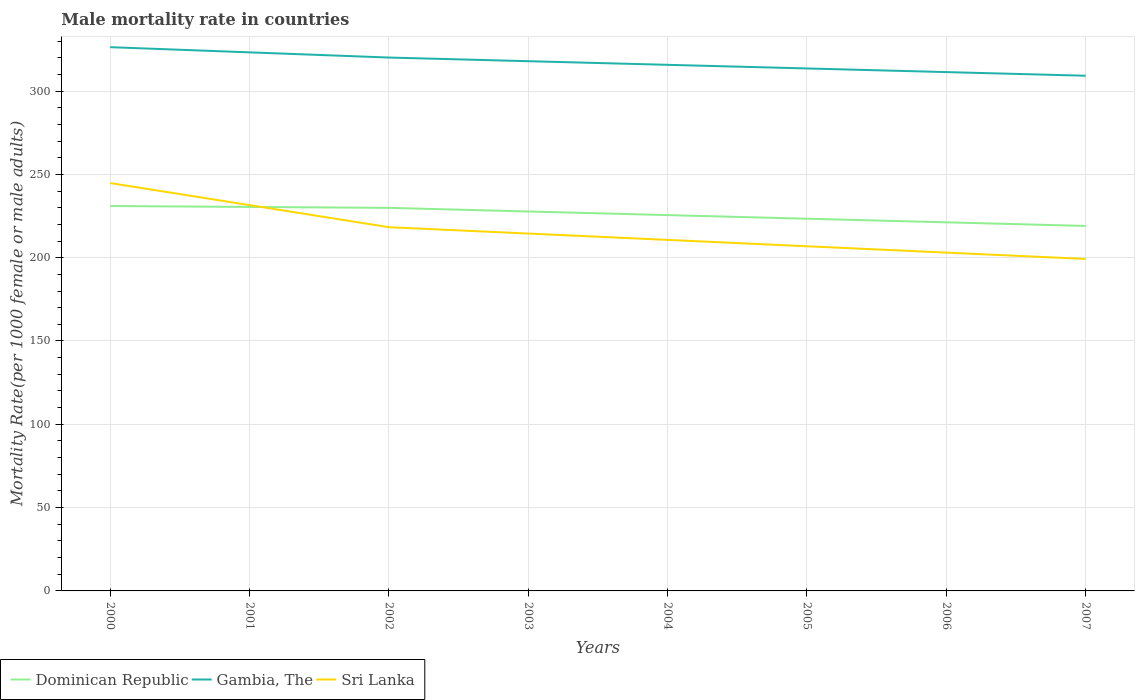How many different coloured lines are there?
Offer a very short reply. 3. Across all years, what is the maximum male mortality rate in Gambia, The?
Provide a succinct answer. 309.21. In which year was the male mortality rate in Sri Lanka maximum?
Give a very brief answer. 2007. What is the total male mortality rate in Sri Lanka in the graph?
Give a very brief answer. 19.05. What is the difference between the highest and the second highest male mortality rate in Gambia, The?
Provide a succinct answer. 17.14. What is the difference between the highest and the lowest male mortality rate in Gambia, The?
Make the answer very short. 4. Is the male mortality rate in Sri Lanka strictly greater than the male mortality rate in Gambia, The over the years?
Offer a very short reply. Yes. How many years are there in the graph?
Offer a very short reply. 8. Are the values on the major ticks of Y-axis written in scientific E-notation?
Make the answer very short. No. Where does the legend appear in the graph?
Keep it short and to the point. Bottom left. What is the title of the graph?
Offer a very short reply. Male mortality rate in countries. What is the label or title of the Y-axis?
Provide a succinct answer. Mortality Rate(per 1000 female or male adults). What is the Mortality Rate(per 1000 female or male adults) of Dominican Republic in 2000?
Keep it short and to the point. 231.02. What is the Mortality Rate(per 1000 female or male adults) of Gambia, The in 2000?
Your answer should be compact. 326.36. What is the Mortality Rate(per 1000 female or male adults) of Sri Lanka in 2000?
Offer a very short reply. 244.79. What is the Mortality Rate(per 1000 female or male adults) in Dominican Republic in 2001?
Make the answer very short. 230.46. What is the Mortality Rate(per 1000 female or male adults) of Gambia, The in 2001?
Ensure brevity in your answer.  323.24. What is the Mortality Rate(per 1000 female or male adults) in Sri Lanka in 2001?
Your answer should be compact. 231.54. What is the Mortality Rate(per 1000 female or male adults) of Dominican Republic in 2002?
Give a very brief answer. 229.91. What is the Mortality Rate(per 1000 female or male adults) in Gambia, The in 2002?
Ensure brevity in your answer.  320.12. What is the Mortality Rate(per 1000 female or male adults) in Sri Lanka in 2002?
Keep it short and to the point. 218.29. What is the Mortality Rate(per 1000 female or male adults) of Dominican Republic in 2003?
Give a very brief answer. 227.74. What is the Mortality Rate(per 1000 female or male adults) of Gambia, The in 2003?
Provide a succinct answer. 317.94. What is the Mortality Rate(per 1000 female or male adults) of Sri Lanka in 2003?
Offer a very short reply. 214.48. What is the Mortality Rate(per 1000 female or male adults) in Dominican Republic in 2004?
Provide a short and direct response. 225.56. What is the Mortality Rate(per 1000 female or male adults) in Gambia, The in 2004?
Make the answer very short. 315.76. What is the Mortality Rate(per 1000 female or male adults) in Sri Lanka in 2004?
Give a very brief answer. 210.67. What is the Mortality Rate(per 1000 female or male adults) of Dominican Republic in 2005?
Give a very brief answer. 223.39. What is the Mortality Rate(per 1000 female or male adults) of Gambia, The in 2005?
Offer a very short reply. 313.58. What is the Mortality Rate(per 1000 female or male adults) of Sri Lanka in 2005?
Give a very brief answer. 206.86. What is the Mortality Rate(per 1000 female or male adults) in Dominican Republic in 2006?
Your answer should be very brief. 221.22. What is the Mortality Rate(per 1000 female or male adults) in Gambia, The in 2006?
Your answer should be compact. 311.39. What is the Mortality Rate(per 1000 female or male adults) in Sri Lanka in 2006?
Provide a succinct answer. 203.05. What is the Mortality Rate(per 1000 female or male adults) of Dominican Republic in 2007?
Offer a very short reply. 219.05. What is the Mortality Rate(per 1000 female or male adults) of Gambia, The in 2007?
Provide a succinct answer. 309.21. What is the Mortality Rate(per 1000 female or male adults) in Sri Lanka in 2007?
Your answer should be compact. 199.24. Across all years, what is the maximum Mortality Rate(per 1000 female or male adults) in Dominican Republic?
Keep it short and to the point. 231.02. Across all years, what is the maximum Mortality Rate(per 1000 female or male adults) in Gambia, The?
Your answer should be compact. 326.36. Across all years, what is the maximum Mortality Rate(per 1000 female or male adults) in Sri Lanka?
Offer a very short reply. 244.79. Across all years, what is the minimum Mortality Rate(per 1000 female or male adults) of Dominican Republic?
Make the answer very short. 219.05. Across all years, what is the minimum Mortality Rate(per 1000 female or male adults) in Gambia, The?
Give a very brief answer. 309.21. Across all years, what is the minimum Mortality Rate(per 1000 female or male adults) in Sri Lanka?
Give a very brief answer. 199.24. What is the total Mortality Rate(per 1000 female or male adults) in Dominican Republic in the graph?
Offer a terse response. 1808.36. What is the total Mortality Rate(per 1000 female or male adults) in Gambia, The in the graph?
Make the answer very short. 2537.6. What is the total Mortality Rate(per 1000 female or male adults) of Sri Lanka in the graph?
Keep it short and to the point. 1728.93. What is the difference between the Mortality Rate(per 1000 female or male adults) of Dominican Republic in 2000 and that in 2001?
Your response must be concise. 0.56. What is the difference between the Mortality Rate(per 1000 female or male adults) in Gambia, The in 2000 and that in 2001?
Offer a terse response. 3.12. What is the difference between the Mortality Rate(per 1000 female or male adults) of Sri Lanka in 2000 and that in 2001?
Offer a terse response. 13.25. What is the difference between the Mortality Rate(per 1000 female or male adults) in Dominican Republic in 2000 and that in 2002?
Keep it short and to the point. 1.11. What is the difference between the Mortality Rate(per 1000 female or male adults) of Gambia, The in 2000 and that in 2002?
Provide a short and direct response. 6.23. What is the difference between the Mortality Rate(per 1000 female or male adults) of Sri Lanka in 2000 and that in 2002?
Your answer should be very brief. 26.5. What is the difference between the Mortality Rate(per 1000 female or male adults) in Dominican Republic in 2000 and that in 2003?
Keep it short and to the point. 3.29. What is the difference between the Mortality Rate(per 1000 female or male adults) in Gambia, The in 2000 and that in 2003?
Give a very brief answer. 8.41. What is the difference between the Mortality Rate(per 1000 female or male adults) in Sri Lanka in 2000 and that in 2003?
Keep it short and to the point. 30.31. What is the difference between the Mortality Rate(per 1000 female or male adults) in Dominican Republic in 2000 and that in 2004?
Your answer should be compact. 5.46. What is the difference between the Mortality Rate(per 1000 female or male adults) in Gambia, The in 2000 and that in 2004?
Keep it short and to the point. 10.6. What is the difference between the Mortality Rate(per 1000 female or male adults) of Sri Lanka in 2000 and that in 2004?
Your response must be concise. 34.12. What is the difference between the Mortality Rate(per 1000 female or male adults) of Dominican Republic in 2000 and that in 2005?
Keep it short and to the point. 7.63. What is the difference between the Mortality Rate(per 1000 female or male adults) in Gambia, The in 2000 and that in 2005?
Offer a very short reply. 12.78. What is the difference between the Mortality Rate(per 1000 female or male adults) in Sri Lanka in 2000 and that in 2005?
Keep it short and to the point. 37.93. What is the difference between the Mortality Rate(per 1000 female or male adults) of Dominican Republic in 2000 and that in 2006?
Make the answer very short. 9.8. What is the difference between the Mortality Rate(per 1000 female or male adults) of Gambia, The in 2000 and that in 2006?
Your answer should be compact. 14.96. What is the difference between the Mortality Rate(per 1000 female or male adults) in Sri Lanka in 2000 and that in 2006?
Keep it short and to the point. 41.74. What is the difference between the Mortality Rate(per 1000 female or male adults) of Dominican Republic in 2000 and that in 2007?
Make the answer very short. 11.97. What is the difference between the Mortality Rate(per 1000 female or male adults) in Gambia, The in 2000 and that in 2007?
Make the answer very short. 17.14. What is the difference between the Mortality Rate(per 1000 female or male adults) of Sri Lanka in 2000 and that in 2007?
Your answer should be very brief. 45.55. What is the difference between the Mortality Rate(per 1000 female or male adults) in Dominican Republic in 2001 and that in 2002?
Keep it short and to the point. 0.56. What is the difference between the Mortality Rate(per 1000 female or male adults) of Gambia, The in 2001 and that in 2002?
Offer a very short reply. 3.12. What is the difference between the Mortality Rate(per 1000 female or male adults) in Sri Lanka in 2001 and that in 2002?
Your answer should be very brief. 13.25. What is the difference between the Mortality Rate(per 1000 female or male adults) of Dominican Republic in 2001 and that in 2003?
Ensure brevity in your answer.  2.73. What is the difference between the Mortality Rate(per 1000 female or male adults) in Gambia, The in 2001 and that in 2003?
Offer a terse response. 5.3. What is the difference between the Mortality Rate(per 1000 female or male adults) in Sri Lanka in 2001 and that in 2003?
Ensure brevity in your answer.  17.06. What is the difference between the Mortality Rate(per 1000 female or male adults) of Dominican Republic in 2001 and that in 2004?
Your answer should be compact. 4.9. What is the difference between the Mortality Rate(per 1000 female or male adults) of Gambia, The in 2001 and that in 2004?
Your answer should be very brief. 7.48. What is the difference between the Mortality Rate(per 1000 female or male adults) in Sri Lanka in 2001 and that in 2004?
Offer a very short reply. 20.87. What is the difference between the Mortality Rate(per 1000 female or male adults) of Dominican Republic in 2001 and that in 2005?
Provide a succinct answer. 7.07. What is the difference between the Mortality Rate(per 1000 female or male adults) of Gambia, The in 2001 and that in 2005?
Your response must be concise. 9.66. What is the difference between the Mortality Rate(per 1000 female or male adults) of Sri Lanka in 2001 and that in 2005?
Your response must be concise. 24.68. What is the difference between the Mortality Rate(per 1000 female or male adults) in Dominican Republic in 2001 and that in 2006?
Provide a succinct answer. 9.24. What is the difference between the Mortality Rate(per 1000 female or male adults) of Gambia, The in 2001 and that in 2006?
Your response must be concise. 11.85. What is the difference between the Mortality Rate(per 1000 female or male adults) of Sri Lanka in 2001 and that in 2006?
Provide a short and direct response. 28.49. What is the difference between the Mortality Rate(per 1000 female or male adults) of Dominican Republic in 2001 and that in 2007?
Your response must be concise. 11.41. What is the difference between the Mortality Rate(per 1000 female or male adults) of Gambia, The in 2001 and that in 2007?
Your answer should be compact. 14.03. What is the difference between the Mortality Rate(per 1000 female or male adults) in Sri Lanka in 2001 and that in 2007?
Provide a short and direct response. 32.3. What is the difference between the Mortality Rate(per 1000 female or male adults) of Dominican Republic in 2002 and that in 2003?
Provide a short and direct response. 2.17. What is the difference between the Mortality Rate(per 1000 female or male adults) of Gambia, The in 2002 and that in 2003?
Make the answer very short. 2.18. What is the difference between the Mortality Rate(per 1000 female or male adults) of Sri Lanka in 2002 and that in 2003?
Your answer should be compact. 3.81. What is the difference between the Mortality Rate(per 1000 female or male adults) in Dominican Republic in 2002 and that in 2004?
Offer a terse response. 4.34. What is the difference between the Mortality Rate(per 1000 female or male adults) of Gambia, The in 2002 and that in 2004?
Your answer should be very brief. 4.37. What is the difference between the Mortality Rate(per 1000 female or male adults) in Sri Lanka in 2002 and that in 2004?
Ensure brevity in your answer.  7.62. What is the difference between the Mortality Rate(per 1000 female or male adults) of Dominican Republic in 2002 and that in 2005?
Your answer should be compact. 6.51. What is the difference between the Mortality Rate(per 1000 female or male adults) in Gambia, The in 2002 and that in 2005?
Offer a terse response. 6.55. What is the difference between the Mortality Rate(per 1000 female or male adults) of Sri Lanka in 2002 and that in 2005?
Offer a terse response. 11.43. What is the difference between the Mortality Rate(per 1000 female or male adults) of Dominican Republic in 2002 and that in 2006?
Provide a short and direct response. 8.69. What is the difference between the Mortality Rate(per 1000 female or male adults) of Gambia, The in 2002 and that in 2006?
Your response must be concise. 8.73. What is the difference between the Mortality Rate(per 1000 female or male adults) in Sri Lanka in 2002 and that in 2006?
Give a very brief answer. 15.24. What is the difference between the Mortality Rate(per 1000 female or male adults) in Dominican Republic in 2002 and that in 2007?
Give a very brief answer. 10.86. What is the difference between the Mortality Rate(per 1000 female or male adults) in Gambia, The in 2002 and that in 2007?
Keep it short and to the point. 10.91. What is the difference between the Mortality Rate(per 1000 female or male adults) in Sri Lanka in 2002 and that in 2007?
Provide a succinct answer. 19.05. What is the difference between the Mortality Rate(per 1000 female or male adults) of Dominican Republic in 2003 and that in 2004?
Provide a short and direct response. 2.17. What is the difference between the Mortality Rate(per 1000 female or male adults) in Gambia, The in 2003 and that in 2004?
Keep it short and to the point. 2.18. What is the difference between the Mortality Rate(per 1000 female or male adults) in Sri Lanka in 2003 and that in 2004?
Provide a short and direct response. 3.81. What is the difference between the Mortality Rate(per 1000 female or male adults) of Dominican Republic in 2003 and that in 2005?
Provide a short and direct response. 4.34. What is the difference between the Mortality Rate(per 1000 female or male adults) of Gambia, The in 2003 and that in 2005?
Offer a very short reply. 4.37. What is the difference between the Mortality Rate(per 1000 female or male adults) of Sri Lanka in 2003 and that in 2005?
Give a very brief answer. 7.62. What is the difference between the Mortality Rate(per 1000 female or male adults) in Dominican Republic in 2003 and that in 2006?
Keep it short and to the point. 6.51. What is the difference between the Mortality Rate(per 1000 female or male adults) in Gambia, The in 2003 and that in 2006?
Your answer should be very brief. 6.55. What is the difference between the Mortality Rate(per 1000 female or male adults) in Sri Lanka in 2003 and that in 2006?
Your answer should be very brief. 11.43. What is the difference between the Mortality Rate(per 1000 female or male adults) of Dominican Republic in 2003 and that in 2007?
Ensure brevity in your answer.  8.68. What is the difference between the Mortality Rate(per 1000 female or male adults) in Gambia, The in 2003 and that in 2007?
Ensure brevity in your answer.  8.73. What is the difference between the Mortality Rate(per 1000 female or male adults) in Sri Lanka in 2003 and that in 2007?
Ensure brevity in your answer.  15.24. What is the difference between the Mortality Rate(per 1000 female or male adults) in Dominican Republic in 2004 and that in 2005?
Offer a very short reply. 2.17. What is the difference between the Mortality Rate(per 1000 female or male adults) in Gambia, The in 2004 and that in 2005?
Keep it short and to the point. 2.18. What is the difference between the Mortality Rate(per 1000 female or male adults) of Sri Lanka in 2004 and that in 2005?
Ensure brevity in your answer.  3.81. What is the difference between the Mortality Rate(per 1000 female or male adults) in Dominican Republic in 2004 and that in 2006?
Your response must be concise. 4.34. What is the difference between the Mortality Rate(per 1000 female or male adults) in Gambia, The in 2004 and that in 2006?
Your answer should be very brief. 4.36. What is the difference between the Mortality Rate(per 1000 female or male adults) of Sri Lanka in 2004 and that in 2006?
Your answer should be compact. 7.62. What is the difference between the Mortality Rate(per 1000 female or male adults) of Dominican Republic in 2004 and that in 2007?
Provide a succinct answer. 6.51. What is the difference between the Mortality Rate(per 1000 female or male adults) in Gambia, The in 2004 and that in 2007?
Your response must be concise. 6.55. What is the difference between the Mortality Rate(per 1000 female or male adults) of Sri Lanka in 2004 and that in 2007?
Offer a very short reply. 11.43. What is the difference between the Mortality Rate(per 1000 female or male adults) of Dominican Republic in 2005 and that in 2006?
Ensure brevity in your answer.  2.17. What is the difference between the Mortality Rate(per 1000 female or male adults) of Gambia, The in 2005 and that in 2006?
Offer a terse response. 2.18. What is the difference between the Mortality Rate(per 1000 female or male adults) of Sri Lanka in 2005 and that in 2006?
Your answer should be compact. 3.81. What is the difference between the Mortality Rate(per 1000 female or male adults) in Dominican Republic in 2005 and that in 2007?
Ensure brevity in your answer.  4.34. What is the difference between the Mortality Rate(per 1000 female or male adults) in Gambia, The in 2005 and that in 2007?
Give a very brief answer. 4.36. What is the difference between the Mortality Rate(per 1000 female or male adults) of Sri Lanka in 2005 and that in 2007?
Keep it short and to the point. 7.62. What is the difference between the Mortality Rate(per 1000 female or male adults) of Dominican Republic in 2006 and that in 2007?
Keep it short and to the point. 2.17. What is the difference between the Mortality Rate(per 1000 female or male adults) in Gambia, The in 2006 and that in 2007?
Give a very brief answer. 2.18. What is the difference between the Mortality Rate(per 1000 female or male adults) in Sri Lanka in 2006 and that in 2007?
Give a very brief answer. 3.81. What is the difference between the Mortality Rate(per 1000 female or male adults) in Dominican Republic in 2000 and the Mortality Rate(per 1000 female or male adults) in Gambia, The in 2001?
Provide a succinct answer. -92.22. What is the difference between the Mortality Rate(per 1000 female or male adults) in Dominican Republic in 2000 and the Mortality Rate(per 1000 female or male adults) in Sri Lanka in 2001?
Your answer should be very brief. -0.52. What is the difference between the Mortality Rate(per 1000 female or male adults) of Gambia, The in 2000 and the Mortality Rate(per 1000 female or male adults) of Sri Lanka in 2001?
Provide a succinct answer. 94.82. What is the difference between the Mortality Rate(per 1000 female or male adults) of Dominican Republic in 2000 and the Mortality Rate(per 1000 female or male adults) of Gambia, The in 2002?
Your response must be concise. -89.1. What is the difference between the Mortality Rate(per 1000 female or male adults) of Dominican Republic in 2000 and the Mortality Rate(per 1000 female or male adults) of Sri Lanka in 2002?
Keep it short and to the point. 12.73. What is the difference between the Mortality Rate(per 1000 female or male adults) in Gambia, The in 2000 and the Mortality Rate(per 1000 female or male adults) in Sri Lanka in 2002?
Offer a very short reply. 108.07. What is the difference between the Mortality Rate(per 1000 female or male adults) of Dominican Republic in 2000 and the Mortality Rate(per 1000 female or male adults) of Gambia, The in 2003?
Your answer should be very brief. -86.92. What is the difference between the Mortality Rate(per 1000 female or male adults) of Dominican Republic in 2000 and the Mortality Rate(per 1000 female or male adults) of Sri Lanka in 2003?
Keep it short and to the point. 16.54. What is the difference between the Mortality Rate(per 1000 female or male adults) in Gambia, The in 2000 and the Mortality Rate(per 1000 female or male adults) in Sri Lanka in 2003?
Offer a very short reply. 111.88. What is the difference between the Mortality Rate(per 1000 female or male adults) in Dominican Republic in 2000 and the Mortality Rate(per 1000 female or male adults) in Gambia, The in 2004?
Make the answer very short. -84.74. What is the difference between the Mortality Rate(per 1000 female or male adults) of Dominican Republic in 2000 and the Mortality Rate(per 1000 female or male adults) of Sri Lanka in 2004?
Make the answer very short. 20.35. What is the difference between the Mortality Rate(per 1000 female or male adults) in Gambia, The in 2000 and the Mortality Rate(per 1000 female or male adults) in Sri Lanka in 2004?
Provide a succinct answer. 115.68. What is the difference between the Mortality Rate(per 1000 female or male adults) of Dominican Republic in 2000 and the Mortality Rate(per 1000 female or male adults) of Gambia, The in 2005?
Your response must be concise. -82.56. What is the difference between the Mortality Rate(per 1000 female or male adults) in Dominican Republic in 2000 and the Mortality Rate(per 1000 female or male adults) in Sri Lanka in 2005?
Provide a short and direct response. 24.16. What is the difference between the Mortality Rate(per 1000 female or male adults) in Gambia, The in 2000 and the Mortality Rate(per 1000 female or male adults) in Sri Lanka in 2005?
Make the answer very short. 119.49. What is the difference between the Mortality Rate(per 1000 female or male adults) of Dominican Republic in 2000 and the Mortality Rate(per 1000 female or male adults) of Gambia, The in 2006?
Provide a short and direct response. -80.37. What is the difference between the Mortality Rate(per 1000 female or male adults) in Dominican Republic in 2000 and the Mortality Rate(per 1000 female or male adults) in Sri Lanka in 2006?
Keep it short and to the point. 27.97. What is the difference between the Mortality Rate(per 1000 female or male adults) of Gambia, The in 2000 and the Mortality Rate(per 1000 female or male adults) of Sri Lanka in 2006?
Offer a very short reply. 123.3. What is the difference between the Mortality Rate(per 1000 female or male adults) of Dominican Republic in 2000 and the Mortality Rate(per 1000 female or male adults) of Gambia, The in 2007?
Make the answer very short. -78.19. What is the difference between the Mortality Rate(per 1000 female or male adults) in Dominican Republic in 2000 and the Mortality Rate(per 1000 female or male adults) in Sri Lanka in 2007?
Your answer should be very brief. 31.78. What is the difference between the Mortality Rate(per 1000 female or male adults) in Gambia, The in 2000 and the Mortality Rate(per 1000 female or male adults) in Sri Lanka in 2007?
Your answer should be compact. 127.11. What is the difference between the Mortality Rate(per 1000 female or male adults) of Dominican Republic in 2001 and the Mortality Rate(per 1000 female or male adults) of Gambia, The in 2002?
Provide a succinct answer. -89.66. What is the difference between the Mortality Rate(per 1000 female or male adults) of Dominican Republic in 2001 and the Mortality Rate(per 1000 female or male adults) of Sri Lanka in 2002?
Provide a succinct answer. 12.17. What is the difference between the Mortality Rate(per 1000 female or male adults) of Gambia, The in 2001 and the Mortality Rate(per 1000 female or male adults) of Sri Lanka in 2002?
Offer a very short reply. 104.95. What is the difference between the Mortality Rate(per 1000 female or male adults) in Dominican Republic in 2001 and the Mortality Rate(per 1000 female or male adults) in Gambia, The in 2003?
Give a very brief answer. -87.48. What is the difference between the Mortality Rate(per 1000 female or male adults) in Dominican Republic in 2001 and the Mortality Rate(per 1000 female or male adults) in Sri Lanka in 2003?
Your response must be concise. 15.98. What is the difference between the Mortality Rate(per 1000 female or male adults) in Gambia, The in 2001 and the Mortality Rate(per 1000 female or male adults) in Sri Lanka in 2003?
Provide a short and direct response. 108.76. What is the difference between the Mortality Rate(per 1000 female or male adults) of Dominican Republic in 2001 and the Mortality Rate(per 1000 female or male adults) of Gambia, The in 2004?
Ensure brevity in your answer.  -85.3. What is the difference between the Mortality Rate(per 1000 female or male adults) in Dominican Republic in 2001 and the Mortality Rate(per 1000 female or male adults) in Sri Lanka in 2004?
Provide a short and direct response. 19.79. What is the difference between the Mortality Rate(per 1000 female or male adults) in Gambia, The in 2001 and the Mortality Rate(per 1000 female or male adults) in Sri Lanka in 2004?
Provide a short and direct response. 112.57. What is the difference between the Mortality Rate(per 1000 female or male adults) in Dominican Republic in 2001 and the Mortality Rate(per 1000 female or male adults) in Gambia, The in 2005?
Your response must be concise. -83.11. What is the difference between the Mortality Rate(per 1000 female or male adults) of Dominican Republic in 2001 and the Mortality Rate(per 1000 female or male adults) of Sri Lanka in 2005?
Provide a succinct answer. 23.6. What is the difference between the Mortality Rate(per 1000 female or male adults) of Gambia, The in 2001 and the Mortality Rate(per 1000 female or male adults) of Sri Lanka in 2005?
Provide a succinct answer. 116.38. What is the difference between the Mortality Rate(per 1000 female or male adults) in Dominican Republic in 2001 and the Mortality Rate(per 1000 female or male adults) in Gambia, The in 2006?
Ensure brevity in your answer.  -80.93. What is the difference between the Mortality Rate(per 1000 female or male adults) in Dominican Republic in 2001 and the Mortality Rate(per 1000 female or male adults) in Sri Lanka in 2006?
Your answer should be compact. 27.41. What is the difference between the Mortality Rate(per 1000 female or male adults) in Gambia, The in 2001 and the Mortality Rate(per 1000 female or male adults) in Sri Lanka in 2006?
Ensure brevity in your answer.  120.19. What is the difference between the Mortality Rate(per 1000 female or male adults) of Dominican Republic in 2001 and the Mortality Rate(per 1000 female or male adults) of Gambia, The in 2007?
Make the answer very short. -78.75. What is the difference between the Mortality Rate(per 1000 female or male adults) in Dominican Republic in 2001 and the Mortality Rate(per 1000 female or male adults) in Sri Lanka in 2007?
Provide a succinct answer. 31.22. What is the difference between the Mortality Rate(per 1000 female or male adults) in Gambia, The in 2001 and the Mortality Rate(per 1000 female or male adults) in Sri Lanka in 2007?
Provide a short and direct response. 124. What is the difference between the Mortality Rate(per 1000 female or male adults) in Dominican Republic in 2002 and the Mortality Rate(per 1000 female or male adults) in Gambia, The in 2003?
Offer a terse response. -88.03. What is the difference between the Mortality Rate(per 1000 female or male adults) in Dominican Republic in 2002 and the Mortality Rate(per 1000 female or male adults) in Sri Lanka in 2003?
Your response must be concise. 15.43. What is the difference between the Mortality Rate(per 1000 female or male adults) of Gambia, The in 2002 and the Mortality Rate(per 1000 female or male adults) of Sri Lanka in 2003?
Ensure brevity in your answer.  105.64. What is the difference between the Mortality Rate(per 1000 female or male adults) in Dominican Republic in 2002 and the Mortality Rate(per 1000 female or male adults) in Gambia, The in 2004?
Provide a short and direct response. -85.85. What is the difference between the Mortality Rate(per 1000 female or male adults) of Dominican Republic in 2002 and the Mortality Rate(per 1000 female or male adults) of Sri Lanka in 2004?
Your answer should be compact. 19.24. What is the difference between the Mortality Rate(per 1000 female or male adults) of Gambia, The in 2002 and the Mortality Rate(per 1000 female or male adults) of Sri Lanka in 2004?
Give a very brief answer. 109.45. What is the difference between the Mortality Rate(per 1000 female or male adults) of Dominican Republic in 2002 and the Mortality Rate(per 1000 female or male adults) of Gambia, The in 2005?
Your answer should be compact. -83.67. What is the difference between the Mortality Rate(per 1000 female or male adults) of Dominican Republic in 2002 and the Mortality Rate(per 1000 female or male adults) of Sri Lanka in 2005?
Your response must be concise. 23.05. What is the difference between the Mortality Rate(per 1000 female or male adults) in Gambia, The in 2002 and the Mortality Rate(per 1000 female or male adults) in Sri Lanka in 2005?
Make the answer very short. 113.26. What is the difference between the Mortality Rate(per 1000 female or male adults) of Dominican Republic in 2002 and the Mortality Rate(per 1000 female or male adults) of Gambia, The in 2006?
Your answer should be very brief. -81.49. What is the difference between the Mortality Rate(per 1000 female or male adults) of Dominican Republic in 2002 and the Mortality Rate(per 1000 female or male adults) of Sri Lanka in 2006?
Give a very brief answer. 26.85. What is the difference between the Mortality Rate(per 1000 female or male adults) in Gambia, The in 2002 and the Mortality Rate(per 1000 female or male adults) in Sri Lanka in 2006?
Provide a short and direct response. 117.07. What is the difference between the Mortality Rate(per 1000 female or male adults) in Dominican Republic in 2002 and the Mortality Rate(per 1000 female or male adults) in Gambia, The in 2007?
Make the answer very short. -79.31. What is the difference between the Mortality Rate(per 1000 female or male adults) in Dominican Republic in 2002 and the Mortality Rate(per 1000 female or male adults) in Sri Lanka in 2007?
Give a very brief answer. 30.66. What is the difference between the Mortality Rate(per 1000 female or male adults) in Gambia, The in 2002 and the Mortality Rate(per 1000 female or male adults) in Sri Lanka in 2007?
Provide a short and direct response. 120.88. What is the difference between the Mortality Rate(per 1000 female or male adults) in Dominican Republic in 2003 and the Mortality Rate(per 1000 female or male adults) in Gambia, The in 2004?
Your answer should be very brief. -88.02. What is the difference between the Mortality Rate(per 1000 female or male adults) in Dominican Republic in 2003 and the Mortality Rate(per 1000 female or male adults) in Sri Lanka in 2004?
Your response must be concise. 17.06. What is the difference between the Mortality Rate(per 1000 female or male adults) of Gambia, The in 2003 and the Mortality Rate(per 1000 female or male adults) of Sri Lanka in 2004?
Ensure brevity in your answer.  107.27. What is the difference between the Mortality Rate(per 1000 female or male adults) of Dominican Republic in 2003 and the Mortality Rate(per 1000 female or male adults) of Gambia, The in 2005?
Offer a terse response. -85.84. What is the difference between the Mortality Rate(per 1000 female or male adults) in Dominican Republic in 2003 and the Mortality Rate(per 1000 female or male adults) in Sri Lanka in 2005?
Give a very brief answer. 20.87. What is the difference between the Mortality Rate(per 1000 female or male adults) of Gambia, The in 2003 and the Mortality Rate(per 1000 female or male adults) of Sri Lanka in 2005?
Provide a short and direct response. 111.08. What is the difference between the Mortality Rate(per 1000 female or male adults) of Dominican Republic in 2003 and the Mortality Rate(per 1000 female or male adults) of Gambia, The in 2006?
Your response must be concise. -83.66. What is the difference between the Mortality Rate(per 1000 female or male adults) of Dominican Republic in 2003 and the Mortality Rate(per 1000 female or male adults) of Sri Lanka in 2006?
Your response must be concise. 24.68. What is the difference between the Mortality Rate(per 1000 female or male adults) of Gambia, The in 2003 and the Mortality Rate(per 1000 female or male adults) of Sri Lanka in 2006?
Offer a very short reply. 114.89. What is the difference between the Mortality Rate(per 1000 female or male adults) of Dominican Republic in 2003 and the Mortality Rate(per 1000 female or male adults) of Gambia, The in 2007?
Offer a terse response. -81.48. What is the difference between the Mortality Rate(per 1000 female or male adults) in Dominican Republic in 2003 and the Mortality Rate(per 1000 female or male adults) in Sri Lanka in 2007?
Offer a very short reply. 28.49. What is the difference between the Mortality Rate(per 1000 female or male adults) in Gambia, The in 2003 and the Mortality Rate(per 1000 female or male adults) in Sri Lanka in 2007?
Keep it short and to the point. 118.7. What is the difference between the Mortality Rate(per 1000 female or male adults) of Dominican Republic in 2004 and the Mortality Rate(per 1000 female or male adults) of Gambia, The in 2005?
Your response must be concise. -88.01. What is the difference between the Mortality Rate(per 1000 female or male adults) in Dominican Republic in 2004 and the Mortality Rate(per 1000 female or male adults) in Sri Lanka in 2005?
Your answer should be very brief. 18.7. What is the difference between the Mortality Rate(per 1000 female or male adults) of Gambia, The in 2004 and the Mortality Rate(per 1000 female or male adults) of Sri Lanka in 2005?
Offer a very short reply. 108.9. What is the difference between the Mortality Rate(per 1000 female or male adults) of Dominican Republic in 2004 and the Mortality Rate(per 1000 female or male adults) of Gambia, The in 2006?
Keep it short and to the point. -85.83. What is the difference between the Mortality Rate(per 1000 female or male adults) in Dominican Republic in 2004 and the Mortality Rate(per 1000 female or male adults) in Sri Lanka in 2006?
Your response must be concise. 22.51. What is the difference between the Mortality Rate(per 1000 female or male adults) in Gambia, The in 2004 and the Mortality Rate(per 1000 female or male adults) in Sri Lanka in 2006?
Your answer should be very brief. 112.71. What is the difference between the Mortality Rate(per 1000 female or male adults) in Dominican Republic in 2004 and the Mortality Rate(per 1000 female or male adults) in Gambia, The in 2007?
Provide a succinct answer. -83.65. What is the difference between the Mortality Rate(per 1000 female or male adults) in Dominican Republic in 2004 and the Mortality Rate(per 1000 female or male adults) in Sri Lanka in 2007?
Offer a terse response. 26.32. What is the difference between the Mortality Rate(per 1000 female or male adults) in Gambia, The in 2004 and the Mortality Rate(per 1000 female or male adults) in Sri Lanka in 2007?
Your response must be concise. 116.52. What is the difference between the Mortality Rate(per 1000 female or male adults) in Dominican Republic in 2005 and the Mortality Rate(per 1000 female or male adults) in Gambia, The in 2006?
Offer a terse response. -88. What is the difference between the Mortality Rate(per 1000 female or male adults) in Dominican Republic in 2005 and the Mortality Rate(per 1000 female or male adults) in Sri Lanka in 2006?
Give a very brief answer. 20.34. What is the difference between the Mortality Rate(per 1000 female or male adults) of Gambia, The in 2005 and the Mortality Rate(per 1000 female or male adults) of Sri Lanka in 2006?
Your response must be concise. 110.52. What is the difference between the Mortality Rate(per 1000 female or male adults) in Dominican Republic in 2005 and the Mortality Rate(per 1000 female or male adults) in Gambia, The in 2007?
Your answer should be compact. -85.82. What is the difference between the Mortality Rate(per 1000 female or male adults) in Dominican Republic in 2005 and the Mortality Rate(per 1000 female or male adults) in Sri Lanka in 2007?
Make the answer very short. 24.15. What is the difference between the Mortality Rate(per 1000 female or male adults) in Gambia, The in 2005 and the Mortality Rate(per 1000 female or male adults) in Sri Lanka in 2007?
Your answer should be very brief. 114.33. What is the difference between the Mortality Rate(per 1000 female or male adults) of Dominican Republic in 2006 and the Mortality Rate(per 1000 female or male adults) of Gambia, The in 2007?
Provide a succinct answer. -87.99. What is the difference between the Mortality Rate(per 1000 female or male adults) in Dominican Republic in 2006 and the Mortality Rate(per 1000 female or male adults) in Sri Lanka in 2007?
Provide a short and direct response. 21.98. What is the difference between the Mortality Rate(per 1000 female or male adults) in Gambia, The in 2006 and the Mortality Rate(per 1000 female or male adults) in Sri Lanka in 2007?
Make the answer very short. 112.15. What is the average Mortality Rate(per 1000 female or male adults) in Dominican Republic per year?
Provide a succinct answer. 226.04. What is the average Mortality Rate(per 1000 female or male adults) of Gambia, The per year?
Make the answer very short. 317.2. What is the average Mortality Rate(per 1000 female or male adults) of Sri Lanka per year?
Offer a very short reply. 216.12. In the year 2000, what is the difference between the Mortality Rate(per 1000 female or male adults) of Dominican Republic and Mortality Rate(per 1000 female or male adults) of Gambia, The?
Your response must be concise. -95.34. In the year 2000, what is the difference between the Mortality Rate(per 1000 female or male adults) of Dominican Republic and Mortality Rate(per 1000 female or male adults) of Sri Lanka?
Offer a terse response. -13.77. In the year 2000, what is the difference between the Mortality Rate(per 1000 female or male adults) in Gambia, The and Mortality Rate(per 1000 female or male adults) in Sri Lanka?
Keep it short and to the point. 81.57. In the year 2001, what is the difference between the Mortality Rate(per 1000 female or male adults) in Dominican Republic and Mortality Rate(per 1000 female or male adults) in Gambia, The?
Give a very brief answer. -92.78. In the year 2001, what is the difference between the Mortality Rate(per 1000 female or male adults) in Dominican Republic and Mortality Rate(per 1000 female or male adults) in Sri Lanka?
Offer a terse response. -1.08. In the year 2001, what is the difference between the Mortality Rate(per 1000 female or male adults) of Gambia, The and Mortality Rate(per 1000 female or male adults) of Sri Lanka?
Make the answer very short. 91.7. In the year 2002, what is the difference between the Mortality Rate(per 1000 female or male adults) in Dominican Republic and Mortality Rate(per 1000 female or male adults) in Gambia, The?
Your answer should be compact. -90.22. In the year 2002, what is the difference between the Mortality Rate(per 1000 female or male adults) in Dominican Republic and Mortality Rate(per 1000 female or male adults) in Sri Lanka?
Provide a short and direct response. 11.62. In the year 2002, what is the difference between the Mortality Rate(per 1000 female or male adults) of Gambia, The and Mortality Rate(per 1000 female or male adults) of Sri Lanka?
Your response must be concise. 101.83. In the year 2003, what is the difference between the Mortality Rate(per 1000 female or male adults) of Dominican Republic and Mortality Rate(per 1000 female or male adults) of Gambia, The?
Your answer should be compact. -90.21. In the year 2003, what is the difference between the Mortality Rate(per 1000 female or male adults) in Dominican Republic and Mortality Rate(per 1000 female or male adults) in Sri Lanka?
Give a very brief answer. 13.25. In the year 2003, what is the difference between the Mortality Rate(per 1000 female or male adults) of Gambia, The and Mortality Rate(per 1000 female or male adults) of Sri Lanka?
Provide a succinct answer. 103.46. In the year 2004, what is the difference between the Mortality Rate(per 1000 female or male adults) in Dominican Republic and Mortality Rate(per 1000 female or male adults) in Gambia, The?
Give a very brief answer. -90.19. In the year 2004, what is the difference between the Mortality Rate(per 1000 female or male adults) in Dominican Republic and Mortality Rate(per 1000 female or male adults) in Sri Lanka?
Provide a succinct answer. 14.89. In the year 2004, what is the difference between the Mortality Rate(per 1000 female or male adults) of Gambia, The and Mortality Rate(per 1000 female or male adults) of Sri Lanka?
Give a very brief answer. 105.09. In the year 2005, what is the difference between the Mortality Rate(per 1000 female or male adults) of Dominican Republic and Mortality Rate(per 1000 female or male adults) of Gambia, The?
Ensure brevity in your answer.  -90.18. In the year 2005, what is the difference between the Mortality Rate(per 1000 female or male adults) of Dominican Republic and Mortality Rate(per 1000 female or male adults) of Sri Lanka?
Ensure brevity in your answer.  16.53. In the year 2005, what is the difference between the Mortality Rate(per 1000 female or male adults) of Gambia, The and Mortality Rate(per 1000 female or male adults) of Sri Lanka?
Keep it short and to the point. 106.71. In the year 2006, what is the difference between the Mortality Rate(per 1000 female or male adults) in Dominican Republic and Mortality Rate(per 1000 female or male adults) in Gambia, The?
Make the answer very short. -90.17. In the year 2006, what is the difference between the Mortality Rate(per 1000 female or male adults) in Dominican Republic and Mortality Rate(per 1000 female or male adults) in Sri Lanka?
Make the answer very short. 18.17. In the year 2006, what is the difference between the Mortality Rate(per 1000 female or male adults) of Gambia, The and Mortality Rate(per 1000 female or male adults) of Sri Lanka?
Your answer should be very brief. 108.34. In the year 2007, what is the difference between the Mortality Rate(per 1000 female or male adults) in Dominican Republic and Mortality Rate(per 1000 female or male adults) in Gambia, The?
Your response must be concise. -90.16. In the year 2007, what is the difference between the Mortality Rate(per 1000 female or male adults) of Dominican Republic and Mortality Rate(per 1000 female or male adults) of Sri Lanka?
Make the answer very short. 19.81. In the year 2007, what is the difference between the Mortality Rate(per 1000 female or male adults) of Gambia, The and Mortality Rate(per 1000 female or male adults) of Sri Lanka?
Make the answer very short. 109.97. What is the ratio of the Mortality Rate(per 1000 female or male adults) of Gambia, The in 2000 to that in 2001?
Your answer should be compact. 1.01. What is the ratio of the Mortality Rate(per 1000 female or male adults) in Sri Lanka in 2000 to that in 2001?
Provide a succinct answer. 1.06. What is the ratio of the Mortality Rate(per 1000 female or male adults) of Dominican Republic in 2000 to that in 2002?
Provide a succinct answer. 1. What is the ratio of the Mortality Rate(per 1000 female or male adults) in Gambia, The in 2000 to that in 2002?
Your answer should be very brief. 1.02. What is the ratio of the Mortality Rate(per 1000 female or male adults) of Sri Lanka in 2000 to that in 2002?
Offer a very short reply. 1.12. What is the ratio of the Mortality Rate(per 1000 female or male adults) of Dominican Republic in 2000 to that in 2003?
Your response must be concise. 1.01. What is the ratio of the Mortality Rate(per 1000 female or male adults) in Gambia, The in 2000 to that in 2003?
Give a very brief answer. 1.03. What is the ratio of the Mortality Rate(per 1000 female or male adults) of Sri Lanka in 2000 to that in 2003?
Your answer should be very brief. 1.14. What is the ratio of the Mortality Rate(per 1000 female or male adults) of Dominican Republic in 2000 to that in 2004?
Offer a very short reply. 1.02. What is the ratio of the Mortality Rate(per 1000 female or male adults) in Gambia, The in 2000 to that in 2004?
Your response must be concise. 1.03. What is the ratio of the Mortality Rate(per 1000 female or male adults) of Sri Lanka in 2000 to that in 2004?
Give a very brief answer. 1.16. What is the ratio of the Mortality Rate(per 1000 female or male adults) in Dominican Republic in 2000 to that in 2005?
Your response must be concise. 1.03. What is the ratio of the Mortality Rate(per 1000 female or male adults) of Gambia, The in 2000 to that in 2005?
Keep it short and to the point. 1.04. What is the ratio of the Mortality Rate(per 1000 female or male adults) of Sri Lanka in 2000 to that in 2005?
Keep it short and to the point. 1.18. What is the ratio of the Mortality Rate(per 1000 female or male adults) in Dominican Republic in 2000 to that in 2006?
Make the answer very short. 1.04. What is the ratio of the Mortality Rate(per 1000 female or male adults) in Gambia, The in 2000 to that in 2006?
Offer a terse response. 1.05. What is the ratio of the Mortality Rate(per 1000 female or male adults) in Sri Lanka in 2000 to that in 2006?
Provide a succinct answer. 1.21. What is the ratio of the Mortality Rate(per 1000 female or male adults) in Dominican Republic in 2000 to that in 2007?
Your response must be concise. 1.05. What is the ratio of the Mortality Rate(per 1000 female or male adults) in Gambia, The in 2000 to that in 2007?
Provide a succinct answer. 1.06. What is the ratio of the Mortality Rate(per 1000 female or male adults) of Sri Lanka in 2000 to that in 2007?
Ensure brevity in your answer.  1.23. What is the ratio of the Mortality Rate(per 1000 female or male adults) of Dominican Republic in 2001 to that in 2002?
Keep it short and to the point. 1. What is the ratio of the Mortality Rate(per 1000 female or male adults) of Gambia, The in 2001 to that in 2002?
Your answer should be compact. 1.01. What is the ratio of the Mortality Rate(per 1000 female or male adults) of Sri Lanka in 2001 to that in 2002?
Provide a short and direct response. 1.06. What is the ratio of the Mortality Rate(per 1000 female or male adults) in Gambia, The in 2001 to that in 2003?
Provide a short and direct response. 1.02. What is the ratio of the Mortality Rate(per 1000 female or male adults) in Sri Lanka in 2001 to that in 2003?
Give a very brief answer. 1.08. What is the ratio of the Mortality Rate(per 1000 female or male adults) of Dominican Republic in 2001 to that in 2004?
Ensure brevity in your answer.  1.02. What is the ratio of the Mortality Rate(per 1000 female or male adults) of Gambia, The in 2001 to that in 2004?
Your answer should be very brief. 1.02. What is the ratio of the Mortality Rate(per 1000 female or male adults) in Sri Lanka in 2001 to that in 2004?
Offer a terse response. 1.1. What is the ratio of the Mortality Rate(per 1000 female or male adults) of Dominican Republic in 2001 to that in 2005?
Give a very brief answer. 1.03. What is the ratio of the Mortality Rate(per 1000 female or male adults) of Gambia, The in 2001 to that in 2005?
Make the answer very short. 1.03. What is the ratio of the Mortality Rate(per 1000 female or male adults) in Sri Lanka in 2001 to that in 2005?
Provide a succinct answer. 1.12. What is the ratio of the Mortality Rate(per 1000 female or male adults) in Dominican Republic in 2001 to that in 2006?
Ensure brevity in your answer.  1.04. What is the ratio of the Mortality Rate(per 1000 female or male adults) in Gambia, The in 2001 to that in 2006?
Keep it short and to the point. 1.04. What is the ratio of the Mortality Rate(per 1000 female or male adults) of Sri Lanka in 2001 to that in 2006?
Keep it short and to the point. 1.14. What is the ratio of the Mortality Rate(per 1000 female or male adults) in Dominican Republic in 2001 to that in 2007?
Offer a terse response. 1.05. What is the ratio of the Mortality Rate(per 1000 female or male adults) of Gambia, The in 2001 to that in 2007?
Your answer should be very brief. 1.05. What is the ratio of the Mortality Rate(per 1000 female or male adults) of Sri Lanka in 2001 to that in 2007?
Ensure brevity in your answer.  1.16. What is the ratio of the Mortality Rate(per 1000 female or male adults) of Dominican Republic in 2002 to that in 2003?
Provide a succinct answer. 1.01. What is the ratio of the Mortality Rate(per 1000 female or male adults) in Gambia, The in 2002 to that in 2003?
Your answer should be very brief. 1.01. What is the ratio of the Mortality Rate(per 1000 female or male adults) of Sri Lanka in 2002 to that in 2003?
Make the answer very short. 1.02. What is the ratio of the Mortality Rate(per 1000 female or male adults) of Dominican Republic in 2002 to that in 2004?
Make the answer very short. 1.02. What is the ratio of the Mortality Rate(per 1000 female or male adults) of Gambia, The in 2002 to that in 2004?
Offer a terse response. 1.01. What is the ratio of the Mortality Rate(per 1000 female or male adults) of Sri Lanka in 2002 to that in 2004?
Keep it short and to the point. 1.04. What is the ratio of the Mortality Rate(per 1000 female or male adults) of Dominican Republic in 2002 to that in 2005?
Give a very brief answer. 1.03. What is the ratio of the Mortality Rate(per 1000 female or male adults) of Gambia, The in 2002 to that in 2005?
Offer a terse response. 1.02. What is the ratio of the Mortality Rate(per 1000 female or male adults) in Sri Lanka in 2002 to that in 2005?
Make the answer very short. 1.06. What is the ratio of the Mortality Rate(per 1000 female or male adults) in Dominican Republic in 2002 to that in 2006?
Your answer should be compact. 1.04. What is the ratio of the Mortality Rate(per 1000 female or male adults) in Gambia, The in 2002 to that in 2006?
Offer a very short reply. 1.03. What is the ratio of the Mortality Rate(per 1000 female or male adults) of Sri Lanka in 2002 to that in 2006?
Make the answer very short. 1.07. What is the ratio of the Mortality Rate(per 1000 female or male adults) of Dominican Republic in 2002 to that in 2007?
Provide a succinct answer. 1.05. What is the ratio of the Mortality Rate(per 1000 female or male adults) of Gambia, The in 2002 to that in 2007?
Your answer should be compact. 1.04. What is the ratio of the Mortality Rate(per 1000 female or male adults) of Sri Lanka in 2002 to that in 2007?
Make the answer very short. 1.1. What is the ratio of the Mortality Rate(per 1000 female or male adults) in Dominican Republic in 2003 to that in 2004?
Offer a very short reply. 1.01. What is the ratio of the Mortality Rate(per 1000 female or male adults) of Sri Lanka in 2003 to that in 2004?
Keep it short and to the point. 1.02. What is the ratio of the Mortality Rate(per 1000 female or male adults) in Dominican Republic in 2003 to that in 2005?
Provide a succinct answer. 1.02. What is the ratio of the Mortality Rate(per 1000 female or male adults) in Gambia, The in 2003 to that in 2005?
Your answer should be compact. 1.01. What is the ratio of the Mortality Rate(per 1000 female or male adults) in Sri Lanka in 2003 to that in 2005?
Give a very brief answer. 1.04. What is the ratio of the Mortality Rate(per 1000 female or male adults) of Dominican Republic in 2003 to that in 2006?
Provide a succinct answer. 1.03. What is the ratio of the Mortality Rate(per 1000 female or male adults) in Sri Lanka in 2003 to that in 2006?
Provide a succinct answer. 1.06. What is the ratio of the Mortality Rate(per 1000 female or male adults) in Dominican Republic in 2003 to that in 2007?
Provide a short and direct response. 1.04. What is the ratio of the Mortality Rate(per 1000 female or male adults) in Gambia, The in 2003 to that in 2007?
Offer a terse response. 1.03. What is the ratio of the Mortality Rate(per 1000 female or male adults) in Sri Lanka in 2003 to that in 2007?
Provide a short and direct response. 1.08. What is the ratio of the Mortality Rate(per 1000 female or male adults) of Dominican Republic in 2004 to that in 2005?
Offer a very short reply. 1.01. What is the ratio of the Mortality Rate(per 1000 female or male adults) of Gambia, The in 2004 to that in 2005?
Provide a succinct answer. 1.01. What is the ratio of the Mortality Rate(per 1000 female or male adults) in Sri Lanka in 2004 to that in 2005?
Your answer should be compact. 1.02. What is the ratio of the Mortality Rate(per 1000 female or male adults) of Dominican Republic in 2004 to that in 2006?
Offer a very short reply. 1.02. What is the ratio of the Mortality Rate(per 1000 female or male adults) in Gambia, The in 2004 to that in 2006?
Make the answer very short. 1.01. What is the ratio of the Mortality Rate(per 1000 female or male adults) of Sri Lanka in 2004 to that in 2006?
Provide a succinct answer. 1.04. What is the ratio of the Mortality Rate(per 1000 female or male adults) in Dominican Republic in 2004 to that in 2007?
Provide a succinct answer. 1.03. What is the ratio of the Mortality Rate(per 1000 female or male adults) in Gambia, The in 2004 to that in 2007?
Your response must be concise. 1.02. What is the ratio of the Mortality Rate(per 1000 female or male adults) in Sri Lanka in 2004 to that in 2007?
Ensure brevity in your answer.  1.06. What is the ratio of the Mortality Rate(per 1000 female or male adults) of Dominican Republic in 2005 to that in 2006?
Your answer should be compact. 1.01. What is the ratio of the Mortality Rate(per 1000 female or male adults) of Sri Lanka in 2005 to that in 2006?
Provide a short and direct response. 1.02. What is the ratio of the Mortality Rate(per 1000 female or male adults) of Dominican Republic in 2005 to that in 2007?
Offer a terse response. 1.02. What is the ratio of the Mortality Rate(per 1000 female or male adults) in Gambia, The in 2005 to that in 2007?
Ensure brevity in your answer.  1.01. What is the ratio of the Mortality Rate(per 1000 female or male adults) of Sri Lanka in 2005 to that in 2007?
Keep it short and to the point. 1.04. What is the ratio of the Mortality Rate(per 1000 female or male adults) of Dominican Republic in 2006 to that in 2007?
Your answer should be compact. 1.01. What is the ratio of the Mortality Rate(per 1000 female or male adults) of Gambia, The in 2006 to that in 2007?
Offer a very short reply. 1.01. What is the ratio of the Mortality Rate(per 1000 female or male adults) in Sri Lanka in 2006 to that in 2007?
Your answer should be compact. 1.02. What is the difference between the highest and the second highest Mortality Rate(per 1000 female or male adults) in Dominican Republic?
Offer a very short reply. 0.56. What is the difference between the highest and the second highest Mortality Rate(per 1000 female or male adults) of Gambia, The?
Offer a very short reply. 3.12. What is the difference between the highest and the second highest Mortality Rate(per 1000 female or male adults) in Sri Lanka?
Your answer should be compact. 13.25. What is the difference between the highest and the lowest Mortality Rate(per 1000 female or male adults) of Dominican Republic?
Provide a succinct answer. 11.97. What is the difference between the highest and the lowest Mortality Rate(per 1000 female or male adults) in Gambia, The?
Offer a very short reply. 17.14. What is the difference between the highest and the lowest Mortality Rate(per 1000 female or male adults) of Sri Lanka?
Provide a succinct answer. 45.55. 